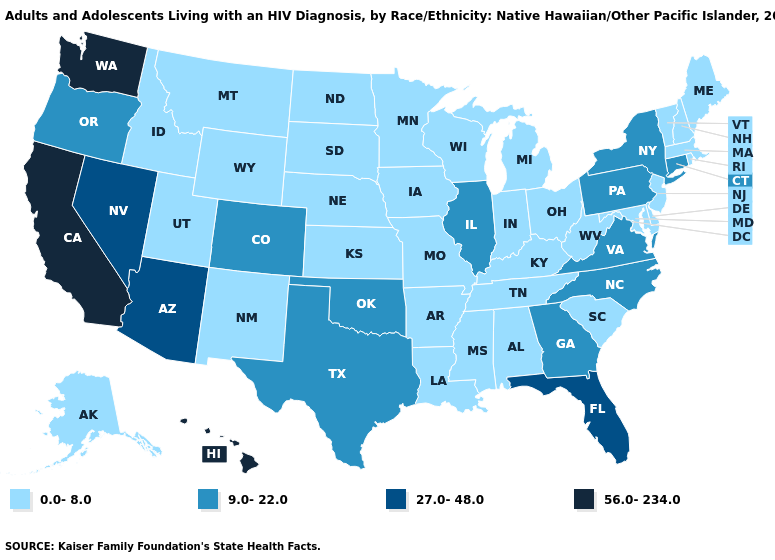Among the states that border Rhode Island , does Connecticut have the highest value?
Write a very short answer. Yes. Does New Jersey have the same value as Alaska?
Short answer required. Yes. Name the states that have a value in the range 0.0-8.0?
Quick response, please. Alabama, Alaska, Arkansas, Delaware, Idaho, Indiana, Iowa, Kansas, Kentucky, Louisiana, Maine, Maryland, Massachusetts, Michigan, Minnesota, Mississippi, Missouri, Montana, Nebraska, New Hampshire, New Jersey, New Mexico, North Dakota, Ohio, Rhode Island, South Carolina, South Dakota, Tennessee, Utah, Vermont, West Virginia, Wisconsin, Wyoming. Does the first symbol in the legend represent the smallest category?
Short answer required. Yes. Does the first symbol in the legend represent the smallest category?
Write a very short answer. Yes. Does Michigan have the same value as North Carolina?
Be succinct. No. What is the value of North Dakota?
Give a very brief answer. 0.0-8.0. Does the map have missing data?
Keep it brief. No. Does California have the highest value in the USA?
Short answer required. Yes. Which states hav the highest value in the South?
Answer briefly. Florida. Which states have the highest value in the USA?
Answer briefly. California, Hawaii, Washington. Does Kentucky have the highest value in the South?
Give a very brief answer. No. Name the states that have a value in the range 27.0-48.0?
Quick response, please. Arizona, Florida, Nevada. What is the lowest value in states that border North Dakota?
Short answer required. 0.0-8.0. Which states have the lowest value in the USA?
Quick response, please. Alabama, Alaska, Arkansas, Delaware, Idaho, Indiana, Iowa, Kansas, Kentucky, Louisiana, Maine, Maryland, Massachusetts, Michigan, Minnesota, Mississippi, Missouri, Montana, Nebraska, New Hampshire, New Jersey, New Mexico, North Dakota, Ohio, Rhode Island, South Carolina, South Dakota, Tennessee, Utah, Vermont, West Virginia, Wisconsin, Wyoming. 